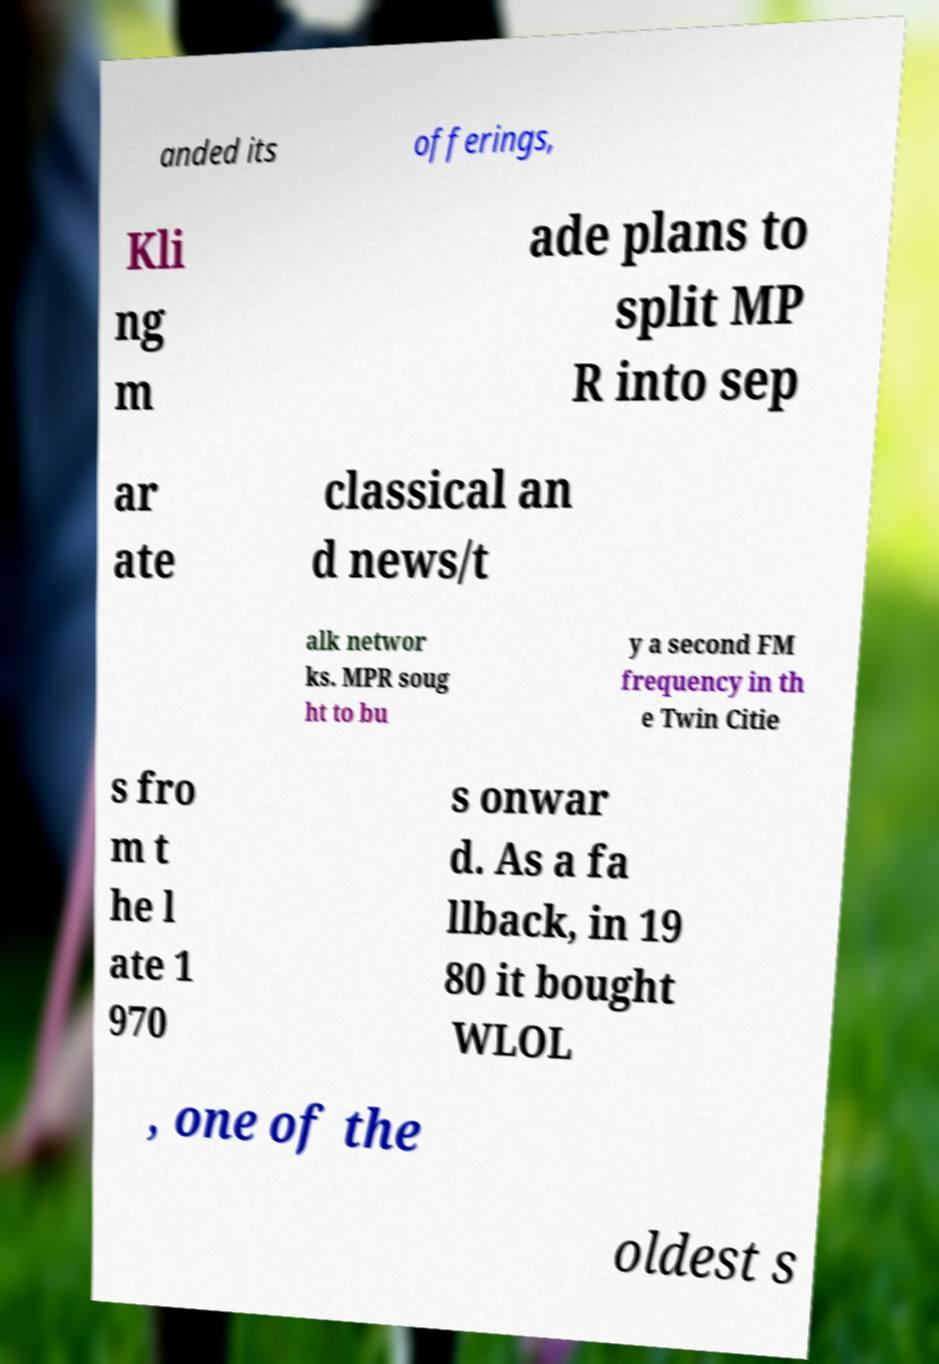There's text embedded in this image that I need extracted. Can you transcribe it verbatim? anded its offerings, Kli ng m ade plans to split MP R into sep ar ate classical an d news/t alk networ ks. MPR soug ht to bu y a second FM frequency in th e Twin Citie s fro m t he l ate 1 970 s onwar d. As a fa llback, in 19 80 it bought WLOL , one of the oldest s 